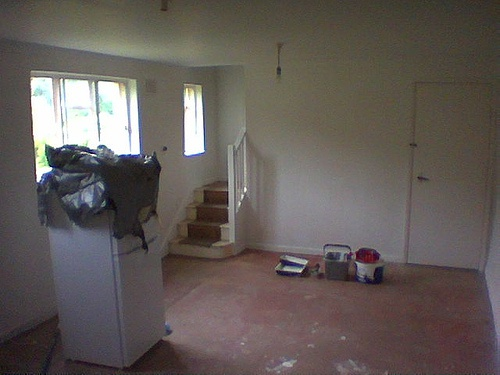Describe the objects in this image and their specific colors. I can see a refrigerator in black and gray tones in this image. 